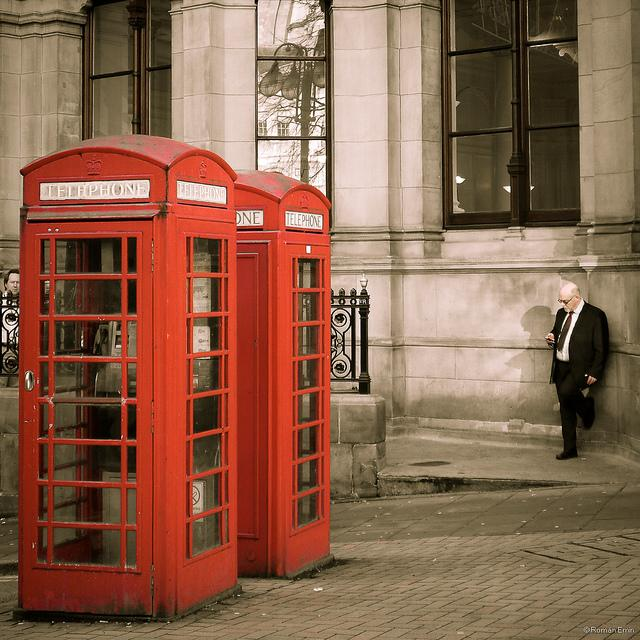If the gentleman here in the suit wants to call his sweetheart where will he do it? phone booth 